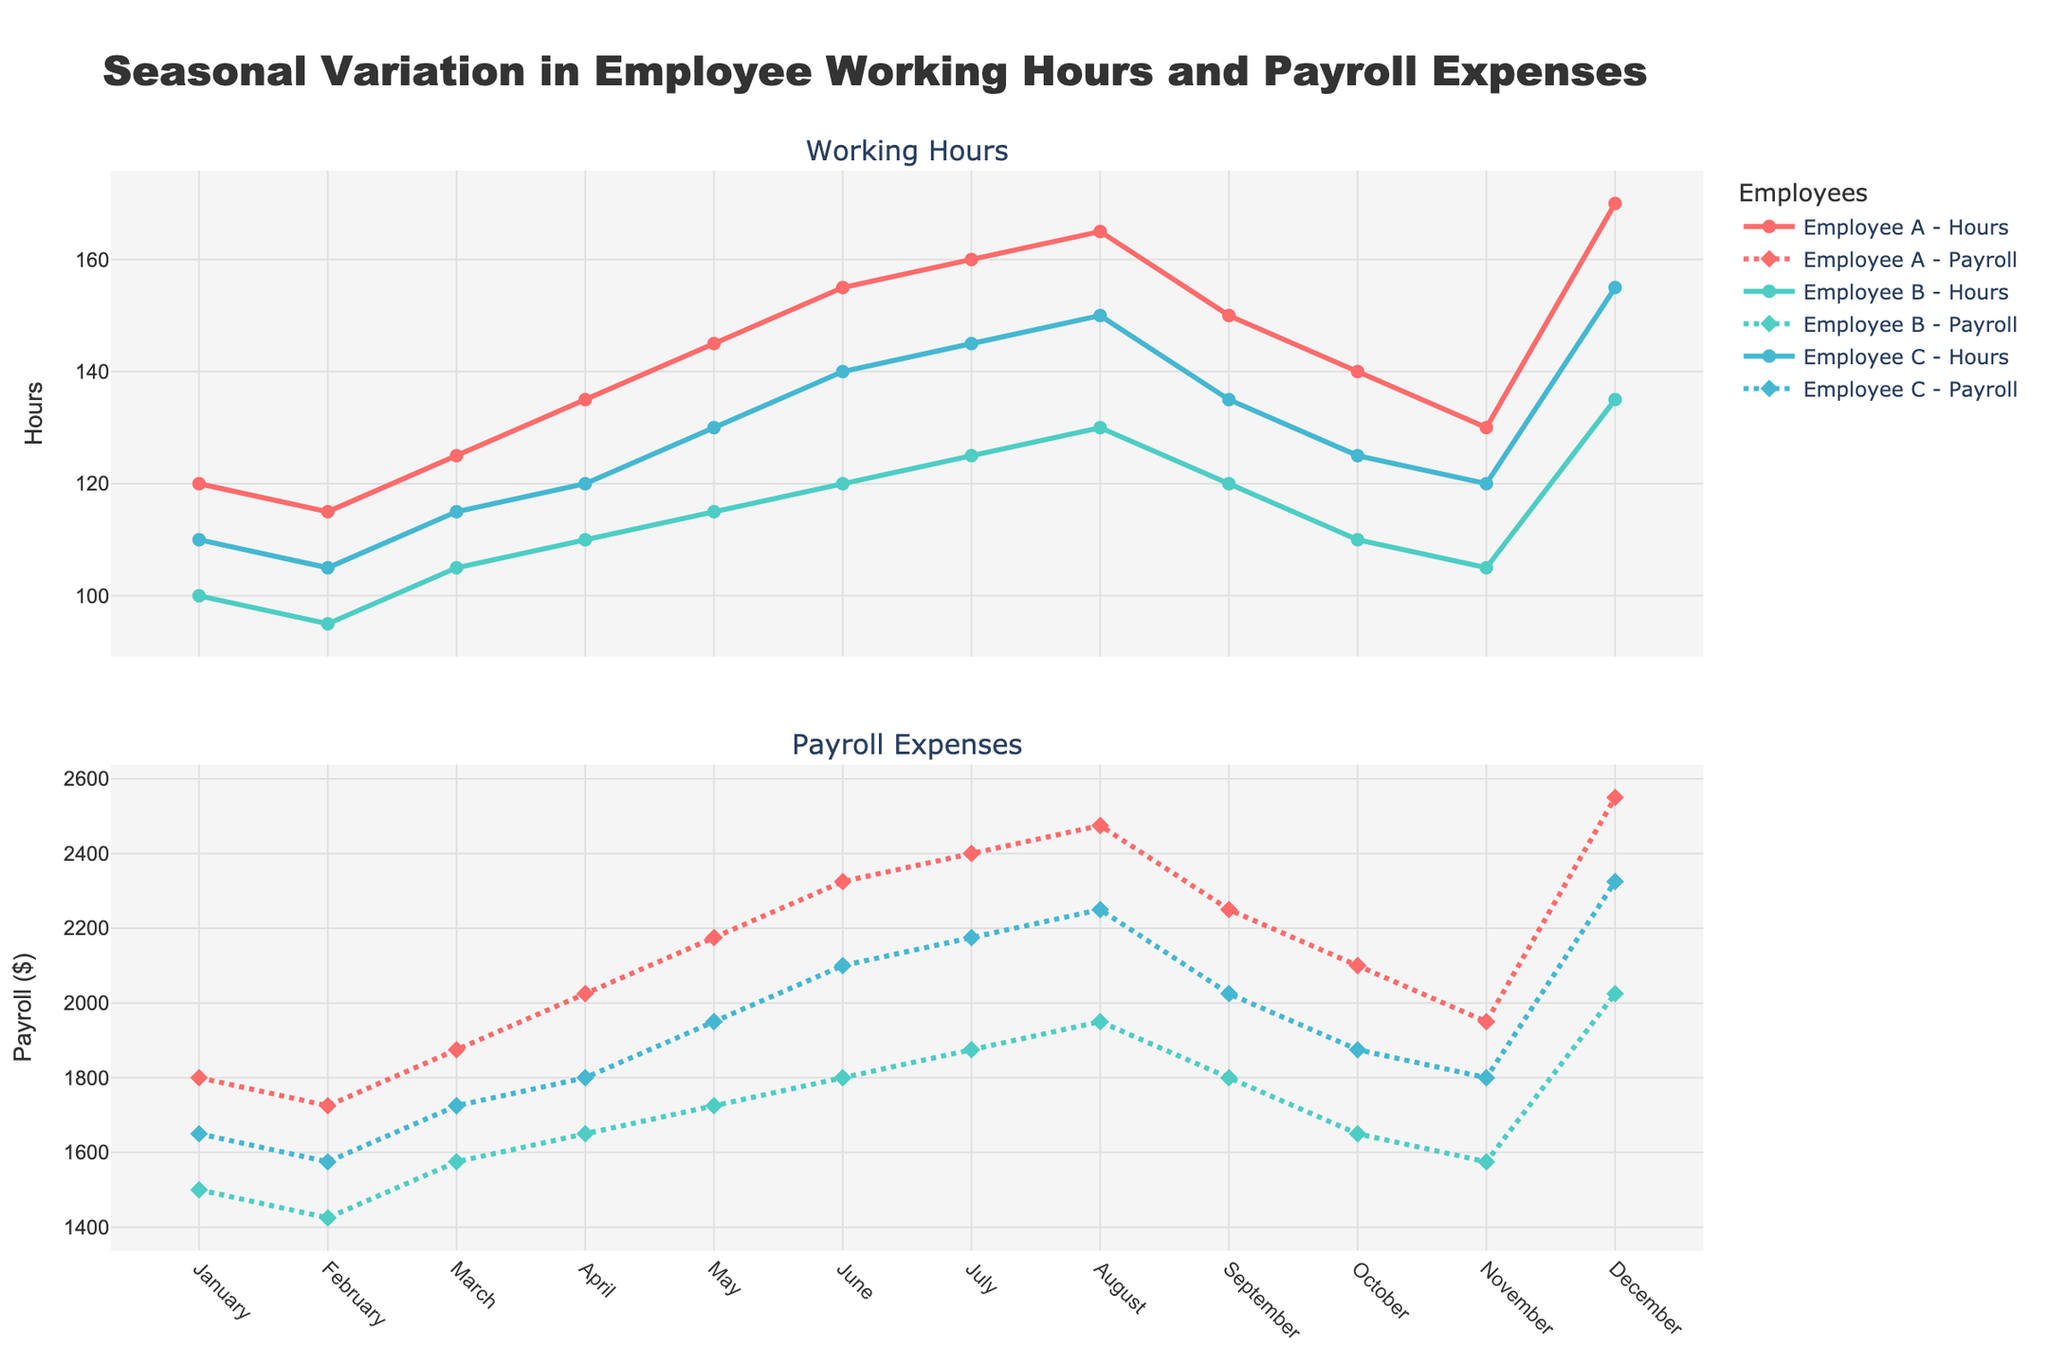Which month shows the highest working hours for Employee A? By looking at the top subplot labeled "Working Hours", Employee A's line peaks in one month. The month with the highest peak is December.
Answer: December Which employee had the lowest payroll in February? By examining the bottom subplot labeled "Payroll Expenses" and focusing on February, the line with the lowest value is for Employee B.
Answer: Employee B What's the difference in working hours between July and January for Employee C? Refer to the top subplot to find Employee C's working hours for July and January. In January, Employee C worked 110 hours, and in July, Employee C worked 145 hours, so the difference is 145 - 110 = 35.
Answer: 35 How do Employee B's working hours change from June to July? Locate June and July on the top subplot for Employee B. In June, the hours are 120, and in July, it increases to 125. Therefore, the change is 125 - 120 = 5.
Answer: 5 In which month do Employee A's payroll expenses first exceed 2000? On the bottom subplot, observe Employee A's payroll trajectory. The first month it surpasses 2000 is in April.
Answer: April What is the overall trend in payroll expenses for Employee B throughout the year? By following Employee B's line in the bottom subplot, it starts around 1500 in January, maintains a plateau until June, gradually increases until August, and dips slightly towards the end of the year.
Answer: Increasing with a plateau and slight dip What month shows the highest combined payroll for all employees? Sum up the payroll values for all employees in each month on the bottom subplot. The highest combined payroll is in December with values 2550 (A) + 2025 (B) + 2325 (C).
Answer: December Which employee had the largest increase in working hours from March to April? Compare the differences in working hours between March and April for all employees on the top subplot. Employee A increased from 125 to 135 (10 hours). Employee B increased from 105 to 110 (5 hours). Employee C increased from 115 to 120 (5 hours). Employee A had the largest increase.
Answer: Employee A What's the average payroll expense for Employee C in the first quarter (January-March)? Calculate the payroll expenses for Employee C in January (1650), February (1575), and March (1725). The average is (1650 + 1575 + 1725) / 3 = 1650.
Answer: 1650 How many times does Employee B's payroll reach above 1900 throughout the year? Count the months on the bottom subplot where Employee B's payroll crosses 1900. It crosses 1900 in July (1950), August (1950), and December (2025), totaling 3 months.
Answer: 3 